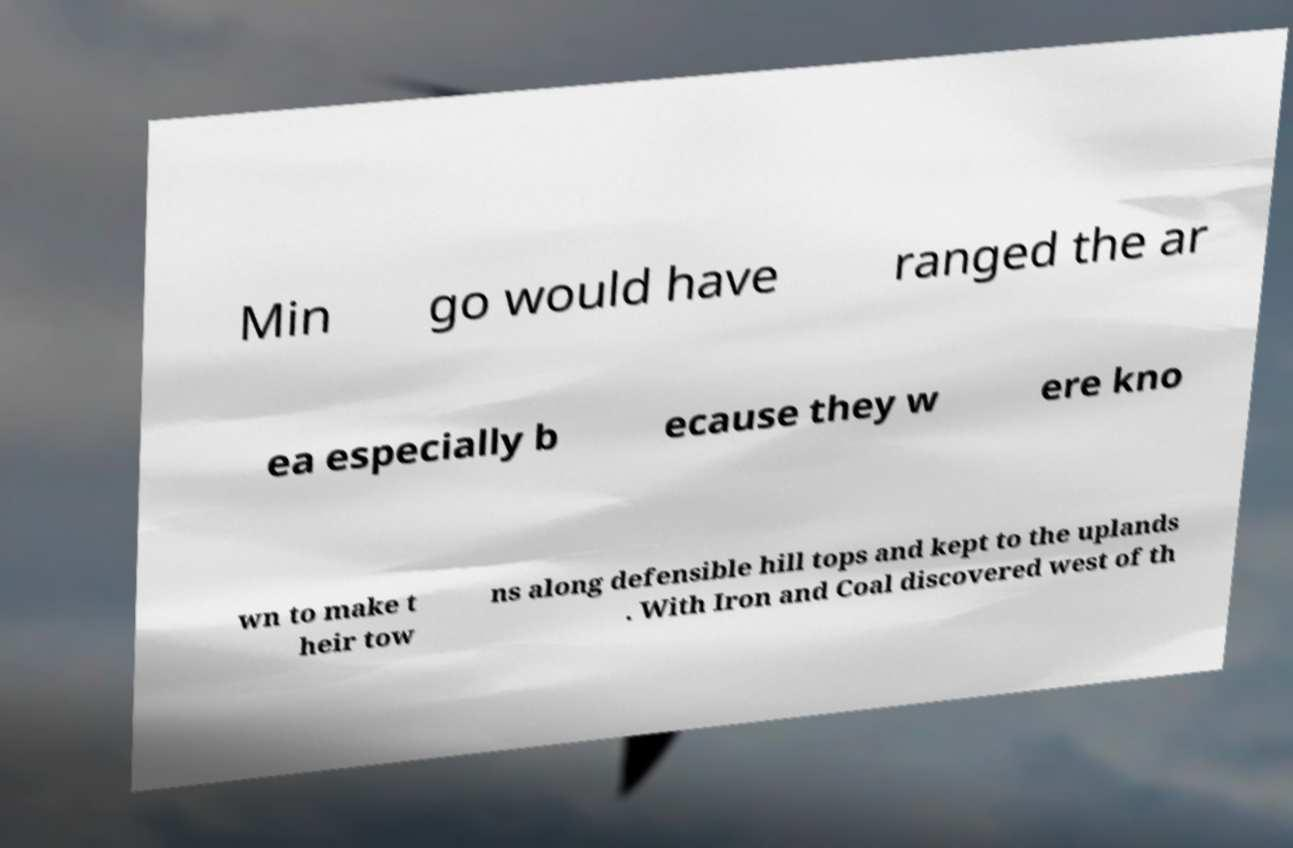Can you accurately transcribe the text from the provided image for me? Min go would have ranged the ar ea especially b ecause they w ere kno wn to make t heir tow ns along defensible hill tops and kept to the uplands . With Iron and Coal discovered west of th 